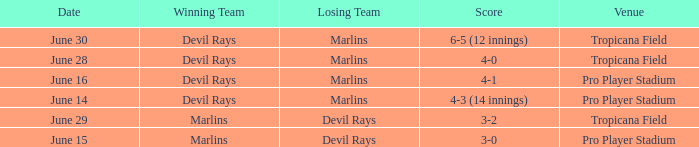What was the score on june 29? 3-2. 